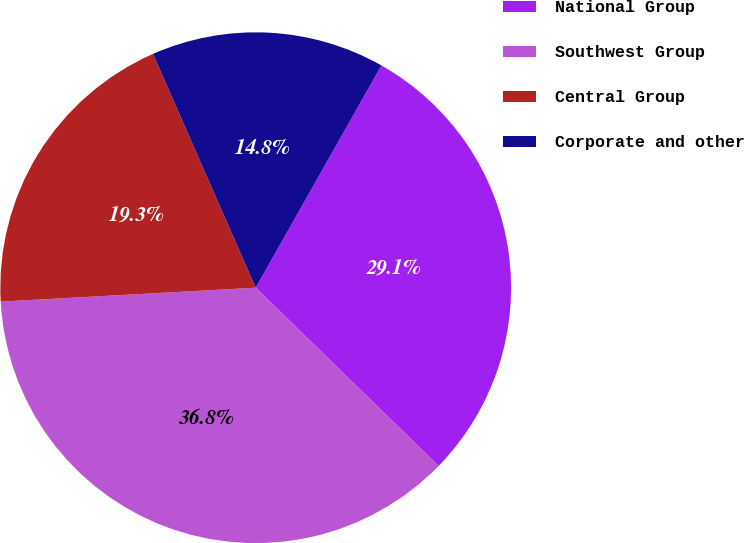Convert chart to OTSL. <chart><loc_0><loc_0><loc_500><loc_500><pie_chart><fcel>National Group<fcel>Southwest Group<fcel>Central Group<fcel>Corporate and other<nl><fcel>29.1%<fcel>36.84%<fcel>19.28%<fcel>14.78%<nl></chart> 